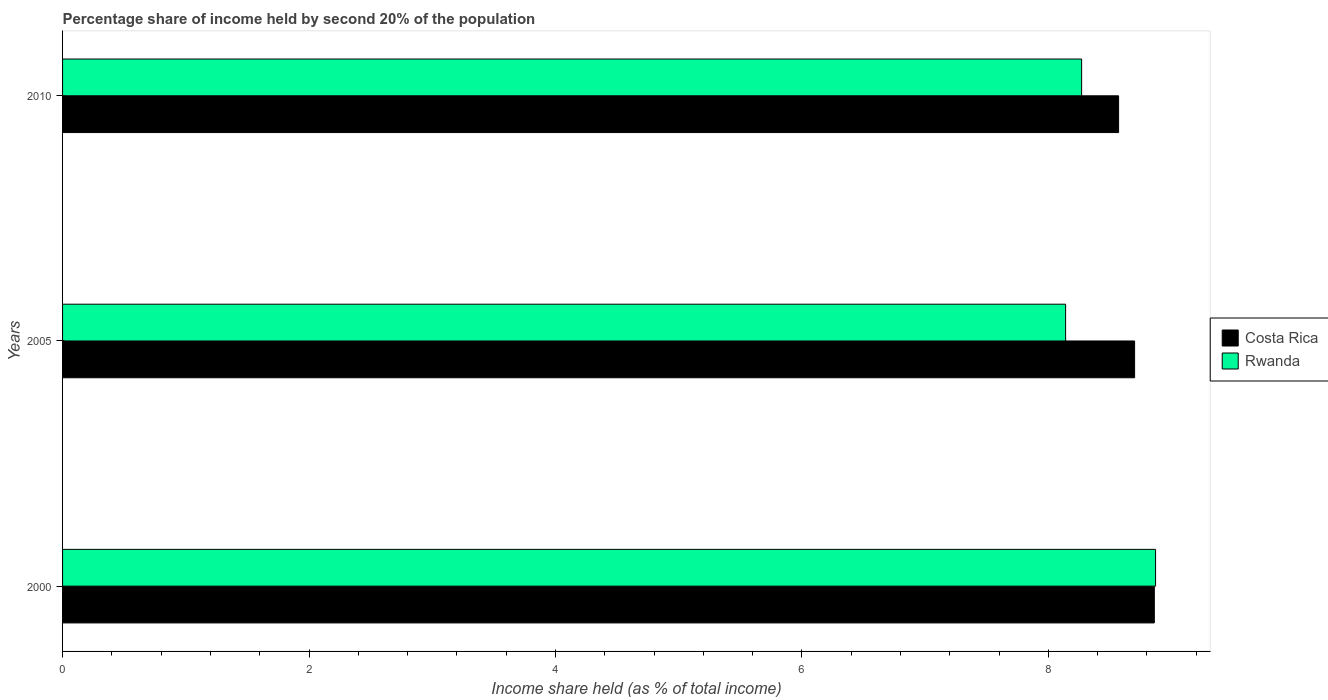How many different coloured bars are there?
Ensure brevity in your answer.  2. How many groups of bars are there?
Keep it short and to the point. 3. How many bars are there on the 3rd tick from the bottom?
Give a very brief answer. 2. What is the share of income held by second 20% of the population in Costa Rica in 2000?
Offer a very short reply. 8.86. Across all years, what is the maximum share of income held by second 20% of the population in Rwanda?
Provide a succinct answer. 8.87. Across all years, what is the minimum share of income held by second 20% of the population in Costa Rica?
Your answer should be very brief. 8.57. In which year was the share of income held by second 20% of the population in Rwanda maximum?
Offer a very short reply. 2000. What is the total share of income held by second 20% of the population in Costa Rica in the graph?
Provide a succinct answer. 26.13. What is the difference between the share of income held by second 20% of the population in Rwanda in 2005 and that in 2010?
Your response must be concise. -0.13. What is the difference between the share of income held by second 20% of the population in Rwanda in 2005 and the share of income held by second 20% of the population in Costa Rica in 2000?
Give a very brief answer. -0.72. What is the average share of income held by second 20% of the population in Rwanda per year?
Make the answer very short. 8.43. In the year 2005, what is the difference between the share of income held by second 20% of the population in Costa Rica and share of income held by second 20% of the population in Rwanda?
Offer a very short reply. 0.56. In how many years, is the share of income held by second 20% of the population in Costa Rica greater than 7.2 %?
Ensure brevity in your answer.  3. What is the ratio of the share of income held by second 20% of the population in Rwanda in 2000 to that in 2010?
Give a very brief answer. 1.07. What is the difference between the highest and the second highest share of income held by second 20% of the population in Rwanda?
Your response must be concise. 0.6. What is the difference between the highest and the lowest share of income held by second 20% of the population in Rwanda?
Your response must be concise. 0.73. In how many years, is the share of income held by second 20% of the population in Rwanda greater than the average share of income held by second 20% of the population in Rwanda taken over all years?
Offer a terse response. 1. What does the 1st bar from the top in 2005 represents?
Give a very brief answer. Rwanda. What does the 2nd bar from the bottom in 2010 represents?
Provide a short and direct response. Rwanda. How many bars are there?
Offer a terse response. 6. Are all the bars in the graph horizontal?
Offer a very short reply. Yes. How many years are there in the graph?
Make the answer very short. 3. What is the difference between two consecutive major ticks on the X-axis?
Your answer should be very brief. 2. How are the legend labels stacked?
Your answer should be compact. Vertical. What is the title of the graph?
Your answer should be compact. Percentage share of income held by second 20% of the population. Does "Uruguay" appear as one of the legend labels in the graph?
Make the answer very short. No. What is the label or title of the X-axis?
Make the answer very short. Income share held (as % of total income). What is the label or title of the Y-axis?
Your answer should be compact. Years. What is the Income share held (as % of total income) in Costa Rica in 2000?
Give a very brief answer. 8.86. What is the Income share held (as % of total income) in Rwanda in 2000?
Provide a short and direct response. 8.87. What is the Income share held (as % of total income) in Costa Rica in 2005?
Make the answer very short. 8.7. What is the Income share held (as % of total income) of Rwanda in 2005?
Offer a terse response. 8.14. What is the Income share held (as % of total income) in Costa Rica in 2010?
Provide a short and direct response. 8.57. What is the Income share held (as % of total income) in Rwanda in 2010?
Ensure brevity in your answer.  8.27. Across all years, what is the maximum Income share held (as % of total income) in Costa Rica?
Provide a succinct answer. 8.86. Across all years, what is the maximum Income share held (as % of total income) of Rwanda?
Offer a very short reply. 8.87. Across all years, what is the minimum Income share held (as % of total income) of Costa Rica?
Offer a terse response. 8.57. Across all years, what is the minimum Income share held (as % of total income) of Rwanda?
Provide a short and direct response. 8.14. What is the total Income share held (as % of total income) of Costa Rica in the graph?
Your answer should be compact. 26.13. What is the total Income share held (as % of total income) of Rwanda in the graph?
Keep it short and to the point. 25.28. What is the difference between the Income share held (as % of total income) of Costa Rica in 2000 and that in 2005?
Offer a terse response. 0.16. What is the difference between the Income share held (as % of total income) in Rwanda in 2000 and that in 2005?
Offer a very short reply. 0.73. What is the difference between the Income share held (as % of total income) in Costa Rica in 2000 and that in 2010?
Keep it short and to the point. 0.29. What is the difference between the Income share held (as % of total income) in Costa Rica in 2005 and that in 2010?
Offer a terse response. 0.13. What is the difference between the Income share held (as % of total income) in Rwanda in 2005 and that in 2010?
Your answer should be very brief. -0.13. What is the difference between the Income share held (as % of total income) of Costa Rica in 2000 and the Income share held (as % of total income) of Rwanda in 2005?
Provide a short and direct response. 0.72. What is the difference between the Income share held (as % of total income) of Costa Rica in 2000 and the Income share held (as % of total income) of Rwanda in 2010?
Your answer should be very brief. 0.59. What is the difference between the Income share held (as % of total income) in Costa Rica in 2005 and the Income share held (as % of total income) in Rwanda in 2010?
Your answer should be very brief. 0.43. What is the average Income share held (as % of total income) in Costa Rica per year?
Make the answer very short. 8.71. What is the average Income share held (as % of total income) in Rwanda per year?
Offer a very short reply. 8.43. In the year 2000, what is the difference between the Income share held (as % of total income) in Costa Rica and Income share held (as % of total income) in Rwanda?
Provide a short and direct response. -0.01. In the year 2005, what is the difference between the Income share held (as % of total income) in Costa Rica and Income share held (as % of total income) in Rwanda?
Your response must be concise. 0.56. What is the ratio of the Income share held (as % of total income) in Costa Rica in 2000 to that in 2005?
Your response must be concise. 1.02. What is the ratio of the Income share held (as % of total income) of Rwanda in 2000 to that in 2005?
Your answer should be compact. 1.09. What is the ratio of the Income share held (as % of total income) in Costa Rica in 2000 to that in 2010?
Offer a very short reply. 1.03. What is the ratio of the Income share held (as % of total income) of Rwanda in 2000 to that in 2010?
Your answer should be very brief. 1.07. What is the ratio of the Income share held (as % of total income) in Costa Rica in 2005 to that in 2010?
Your response must be concise. 1.02. What is the ratio of the Income share held (as % of total income) of Rwanda in 2005 to that in 2010?
Make the answer very short. 0.98. What is the difference between the highest and the second highest Income share held (as % of total income) in Costa Rica?
Offer a terse response. 0.16. What is the difference between the highest and the lowest Income share held (as % of total income) of Costa Rica?
Ensure brevity in your answer.  0.29. What is the difference between the highest and the lowest Income share held (as % of total income) in Rwanda?
Offer a very short reply. 0.73. 